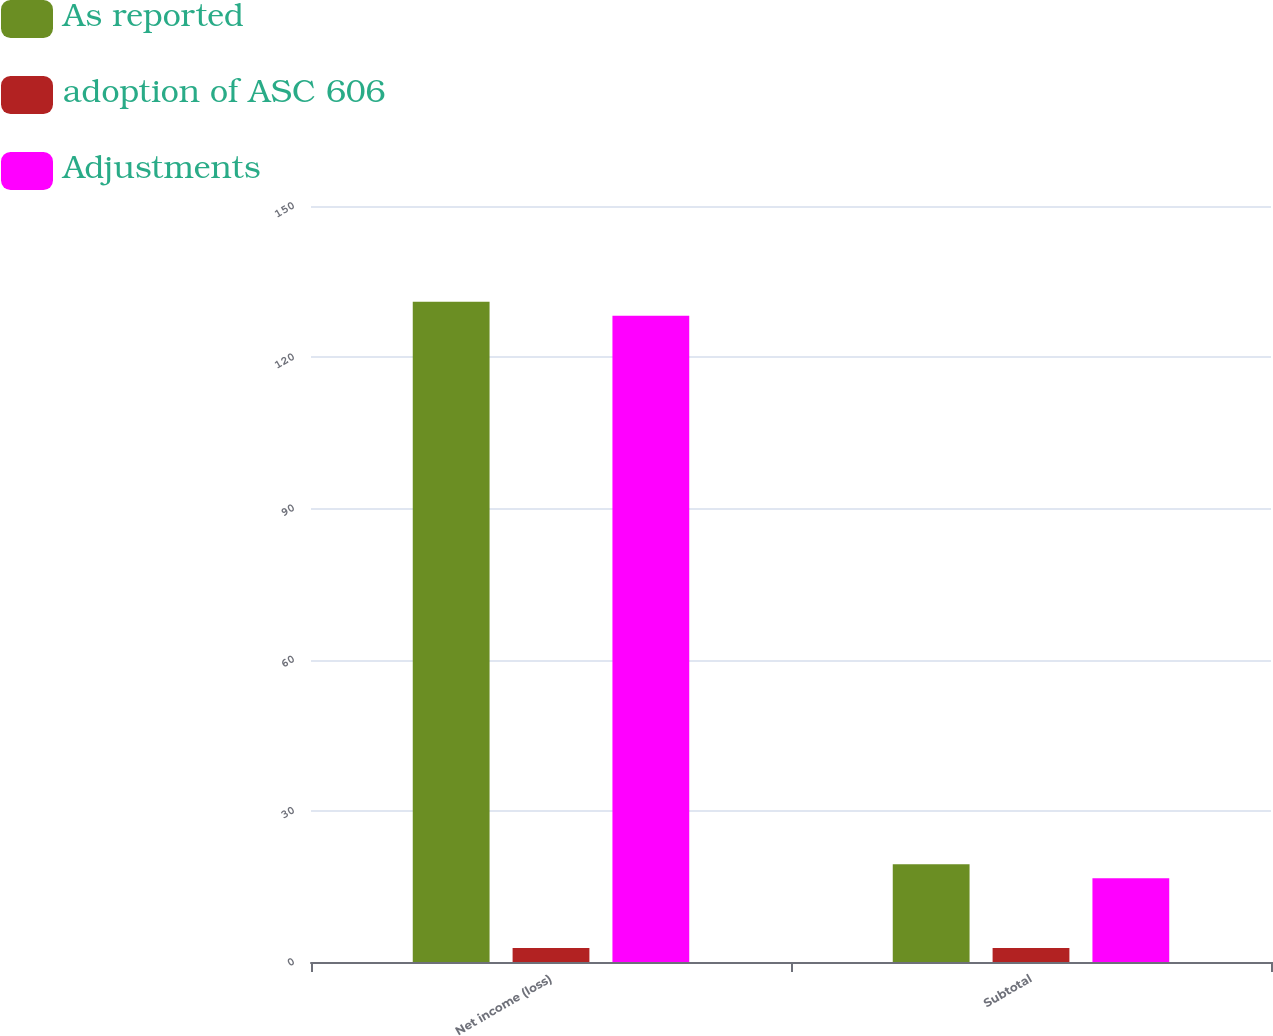Convert chart to OTSL. <chart><loc_0><loc_0><loc_500><loc_500><stacked_bar_chart><ecel><fcel>Net income (loss)<fcel>Subtotal<nl><fcel>As reported<fcel>131<fcel>19.4<nl><fcel>adoption of ASC 606<fcel>2.8<fcel>2.8<nl><fcel>Adjustments<fcel>128.2<fcel>16.6<nl></chart> 